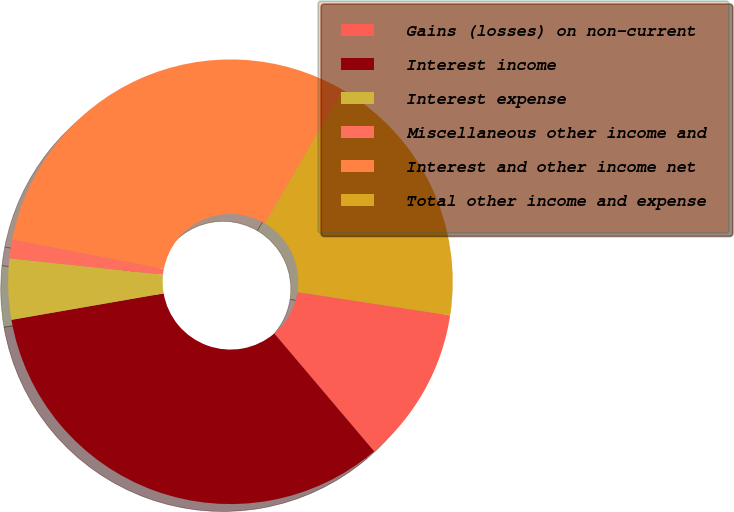Convert chart to OTSL. <chart><loc_0><loc_0><loc_500><loc_500><pie_chart><fcel>Gains (losses) on non-current<fcel>Interest income<fcel>Interest expense<fcel>Miscellaneous other income and<fcel>Interest and other income net<fcel>Total other income and expense<nl><fcel>11.39%<fcel>33.45%<fcel>4.42%<fcel>1.36%<fcel>30.39%<fcel>18.99%<nl></chart> 